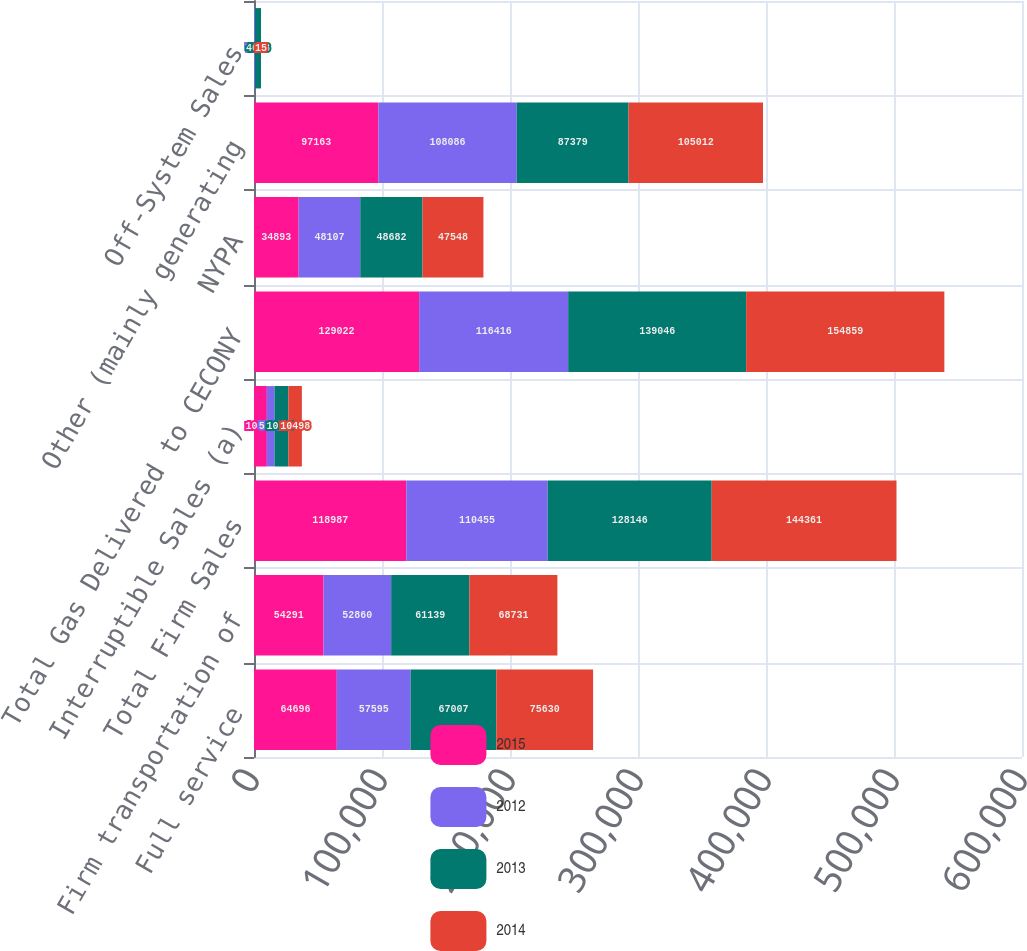Convert chart. <chart><loc_0><loc_0><loc_500><loc_500><stacked_bar_chart><ecel><fcel>Full service<fcel>Firm transportation of<fcel>Total Firm Sales<fcel>Interruptible Sales (a)<fcel>Total Gas Delivered to CECONY<fcel>NYPA<fcel>Other (mainly generating<fcel>Off-System Sales<nl><fcel>2015<fcel>64696<fcel>54291<fcel>118987<fcel>10035<fcel>129022<fcel>34893<fcel>97163<fcel>97<nl><fcel>2012<fcel>57595<fcel>52860<fcel>110455<fcel>5961<fcel>116416<fcel>48107<fcel>108086<fcel>730<nl><fcel>2013<fcel>67007<fcel>61139<fcel>128146<fcel>10900<fcel>139046<fcel>48682<fcel>87379<fcel>4638<nl><fcel>2014<fcel>75630<fcel>68731<fcel>144361<fcel>10498<fcel>154859<fcel>47548<fcel>105012<fcel>15<nl></chart> 